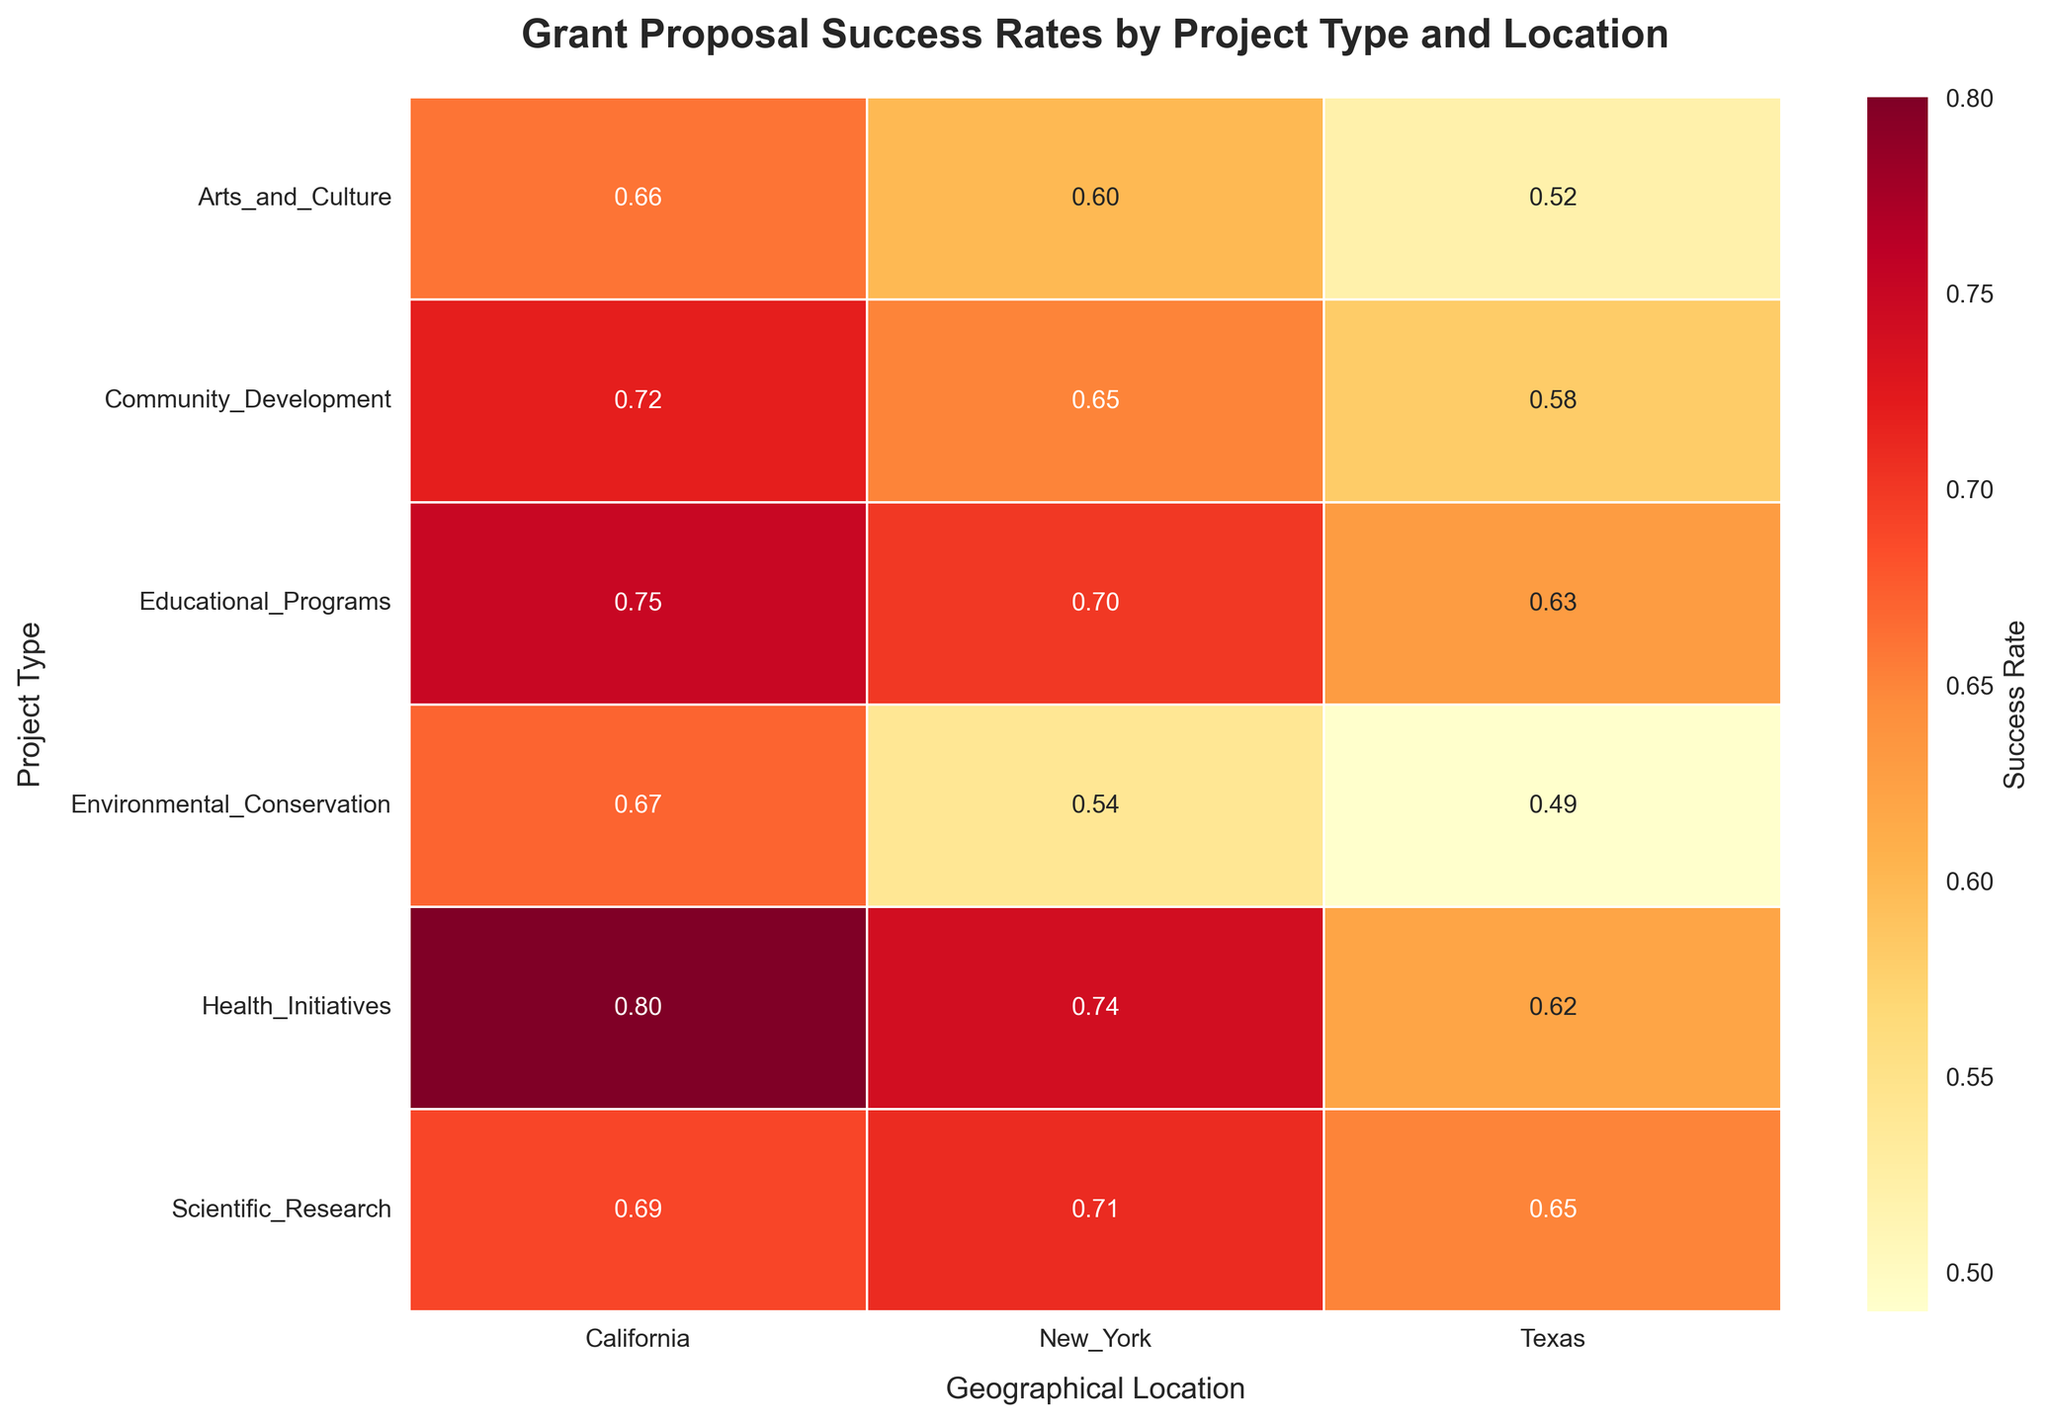What is the color scheme used in the heatmap? The color scheme transitions from yellow to red, representing lower to higher success rates.
Answer: Yellows to reds What is the title of the heatmap? The title is displayed at the top of the heatmap.
Answer: Grant Proposal Success Rates by Project Type and Location Which project type has the highest success rate in California? Look for the highest numerical value among the cells in the California column.
Answer: Health Initiatives In which geographical location do Educational Programs have the lowest success rate? Compare the values in the Educational Programs row and identify the lowest one.
Answer: Texas What is the average success rate for Community Development projects across all geographical locations? Sum the success rates for Community Development (0.72, 0.65, 0.58) and divide by the number of locations (3).
Answer: 0.65 Which project type has the closest success rates across all geographical locations? Compare the differences in success rates for each project type across all locations and identify the smallest range.
Answer: Scientific Research How does the success rate of Health Initiatives in Texas compare to New York? Identify the cells for Health Initiatives in Texas (0.62) and New York (0.74) and compare their values.
Answer: Lower in Texas What is the difference in the success rate of Environmental Conservation between California and Texas? Subtract the success rate in Texas (0.49) from that in California (0.67).
Answer: 0.18 Which geographical location has the most consistent success rates across different project types? Observe the variation in values within each geographical column and determine which has the least variation.
Answer: California Are there any project types that have a success rate above 0.70 in all geographical locations? Check each project type's row for values consistently above 0.70.
Answer: No 